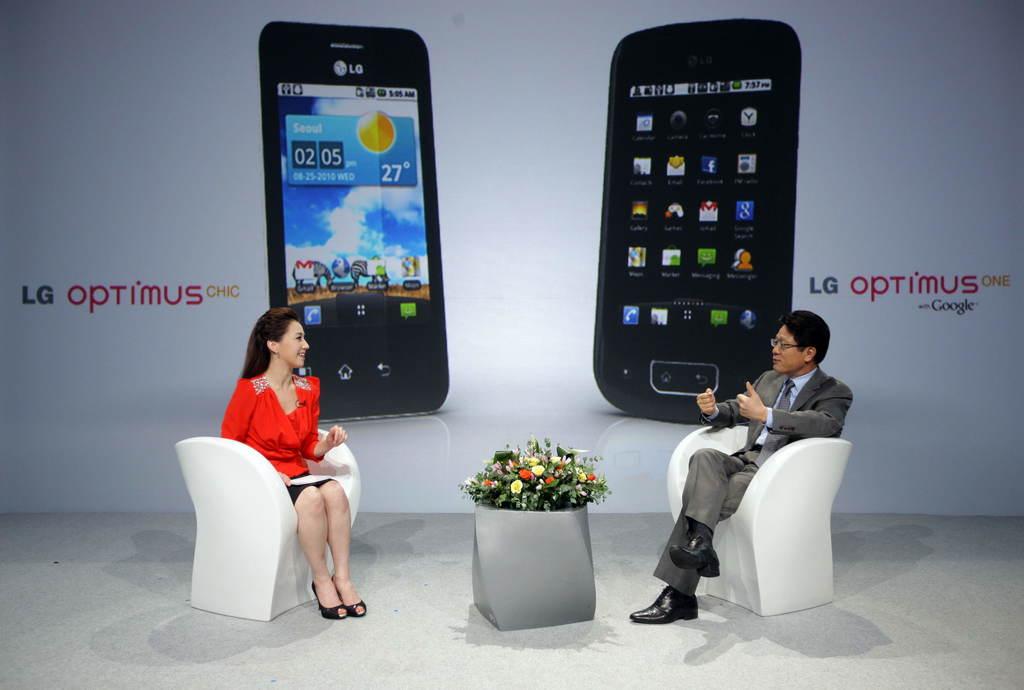What is the weather for seoul?
Provide a succinct answer. Sunny. What is the names of the phones?
Give a very brief answer. Lg optimus. 